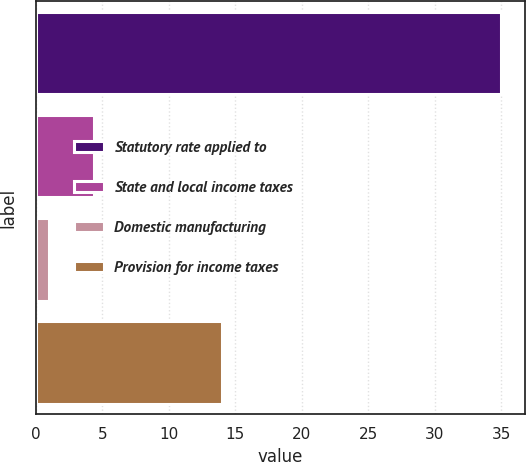<chart> <loc_0><loc_0><loc_500><loc_500><bar_chart><fcel>Statutory rate applied to<fcel>State and local income taxes<fcel>Domestic manufacturing<fcel>Provision for income taxes<nl><fcel>35<fcel>4.4<fcel>1<fcel>14<nl></chart> 